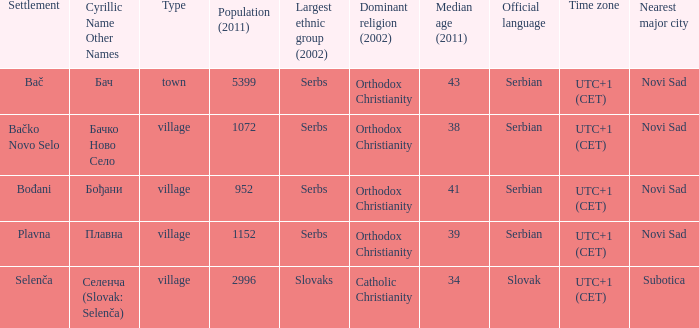What is the second way of writting плавна. Plavna. 